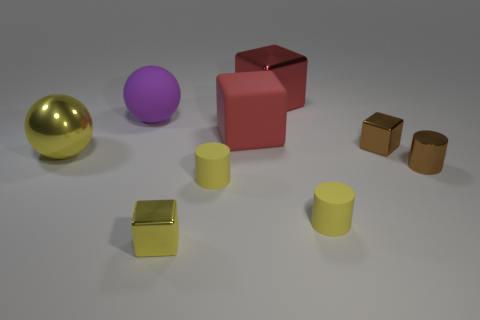What is the material of the tiny block behind the large yellow ball that is in front of the small block behind the yellow block?
Offer a terse response. Metal. Are there any yellow metallic things of the same size as the red matte cube?
Your answer should be very brief. Yes. What is the color of the metal thing to the right of the small brown metal object left of the tiny brown metal cylinder?
Your answer should be compact. Brown. What number of large gray balls are there?
Your response must be concise. 0. Is the color of the large rubber cube the same as the large shiny cube?
Offer a very short reply. Yes. Are there fewer large matte balls on the right side of the tiny brown metallic cube than yellow matte cylinders that are to the left of the big red metal object?
Offer a terse response. Yes. What color is the matte block?
Your answer should be compact. Red. What number of cubes are the same color as the metallic ball?
Your answer should be compact. 1. There is a yellow metal block; are there any yellow shiny spheres right of it?
Provide a succinct answer. No. Are there an equal number of large red objects that are in front of the red metal object and metal objects that are in front of the shiny cylinder?
Your response must be concise. Yes. 